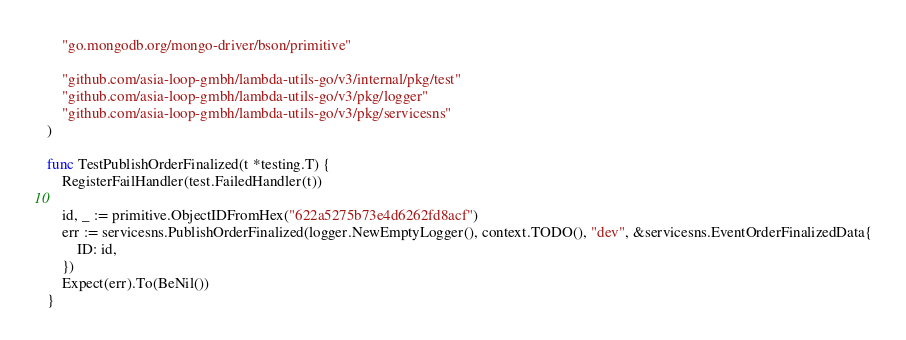<code> <loc_0><loc_0><loc_500><loc_500><_Go_>	"go.mongodb.org/mongo-driver/bson/primitive"

	"github.com/asia-loop-gmbh/lambda-utils-go/v3/internal/pkg/test"
	"github.com/asia-loop-gmbh/lambda-utils-go/v3/pkg/logger"
	"github.com/asia-loop-gmbh/lambda-utils-go/v3/pkg/servicesns"
)

func TestPublishOrderFinalized(t *testing.T) {
	RegisterFailHandler(test.FailedHandler(t))

	id, _ := primitive.ObjectIDFromHex("622a5275b73e4d6262fd8acf")
	err := servicesns.PublishOrderFinalized(logger.NewEmptyLogger(), context.TODO(), "dev", &servicesns.EventOrderFinalizedData{
		ID: id,
	})
	Expect(err).To(BeNil())
}
</code> 